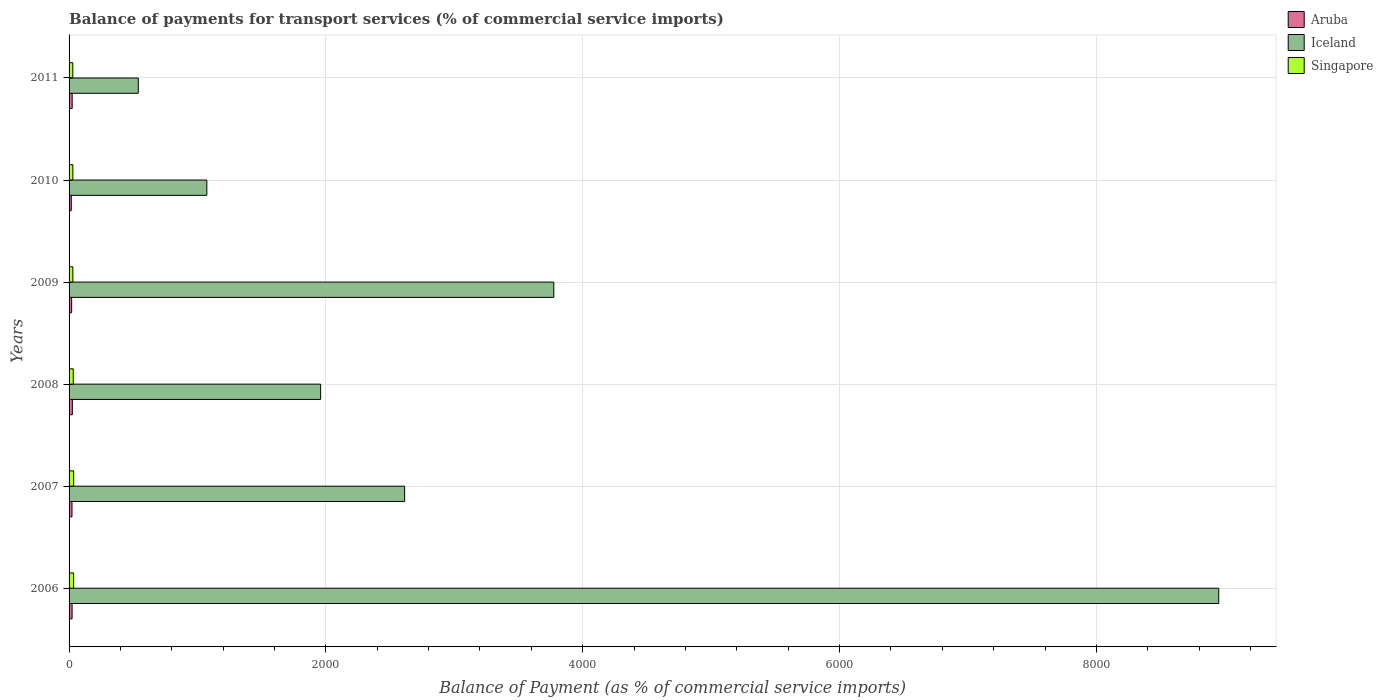How many different coloured bars are there?
Give a very brief answer. 3. Are the number of bars per tick equal to the number of legend labels?
Your response must be concise. Yes. What is the label of the 1st group of bars from the top?
Give a very brief answer. 2011. In how many cases, is the number of bars for a given year not equal to the number of legend labels?
Provide a short and direct response. 0. What is the balance of payments for transport services in Singapore in 2009?
Make the answer very short. 29.54. Across all years, what is the maximum balance of payments for transport services in Aruba?
Offer a terse response. 25.45. Across all years, what is the minimum balance of payments for transport services in Aruba?
Your answer should be compact. 17.18. In which year was the balance of payments for transport services in Aruba maximum?
Keep it short and to the point. 2008. What is the total balance of payments for transport services in Aruba in the graph?
Offer a terse response. 132.74. What is the difference between the balance of payments for transport services in Singapore in 2006 and that in 2008?
Make the answer very short. 2.6. What is the difference between the balance of payments for transport services in Iceland in 2011 and the balance of payments for transport services in Aruba in 2007?
Keep it short and to the point. 516.46. What is the average balance of payments for transport services in Iceland per year?
Keep it short and to the point. 3151.97. In the year 2011, what is the difference between the balance of payments for transport services in Singapore and balance of payments for transport services in Aruba?
Keep it short and to the point. 4.82. What is the ratio of the balance of payments for transport services in Aruba in 2007 to that in 2008?
Offer a very short reply. 0.89. Is the difference between the balance of payments for transport services in Singapore in 2010 and 2011 greater than the difference between the balance of payments for transport services in Aruba in 2010 and 2011?
Ensure brevity in your answer.  Yes. What is the difference between the highest and the second highest balance of payments for transport services in Singapore?
Make the answer very short. 0.41. What is the difference between the highest and the lowest balance of payments for transport services in Aruba?
Your answer should be compact. 8.27. What does the 1st bar from the top in 2006 represents?
Provide a short and direct response. Singapore. What does the 3rd bar from the bottom in 2007 represents?
Your response must be concise. Singapore. Are all the bars in the graph horizontal?
Provide a succinct answer. Yes. How many years are there in the graph?
Ensure brevity in your answer.  6. What is the difference between two consecutive major ticks on the X-axis?
Offer a very short reply. 2000. Does the graph contain any zero values?
Your response must be concise. No. Does the graph contain grids?
Your answer should be very brief. Yes. How many legend labels are there?
Make the answer very short. 3. How are the legend labels stacked?
Provide a short and direct response. Vertical. What is the title of the graph?
Give a very brief answer. Balance of payments for transport services (% of commercial service imports). Does "Paraguay" appear as one of the legend labels in the graph?
Provide a succinct answer. No. What is the label or title of the X-axis?
Offer a terse response. Balance of Payment (as % of commercial service imports). What is the Balance of Payment (as % of commercial service imports) of Aruba in 2006?
Offer a terse response. 23.38. What is the Balance of Payment (as % of commercial service imports) of Iceland in 2006?
Your answer should be compact. 8952.73. What is the Balance of Payment (as % of commercial service imports) in Singapore in 2006?
Make the answer very short. 35.42. What is the Balance of Payment (as % of commercial service imports) of Aruba in 2007?
Provide a short and direct response. 22.61. What is the Balance of Payment (as % of commercial service imports) in Iceland in 2007?
Your answer should be compact. 2613.27. What is the Balance of Payment (as % of commercial service imports) in Singapore in 2007?
Provide a succinct answer. 35.83. What is the Balance of Payment (as % of commercial service imports) of Aruba in 2008?
Your response must be concise. 25.45. What is the Balance of Payment (as % of commercial service imports) in Iceland in 2008?
Provide a short and direct response. 1959.06. What is the Balance of Payment (as % of commercial service imports) in Singapore in 2008?
Provide a succinct answer. 32.82. What is the Balance of Payment (as % of commercial service imports) in Aruba in 2009?
Offer a very short reply. 19.96. What is the Balance of Payment (as % of commercial service imports) of Iceland in 2009?
Your answer should be compact. 3774.93. What is the Balance of Payment (as % of commercial service imports) of Singapore in 2009?
Your answer should be compact. 29.54. What is the Balance of Payment (as % of commercial service imports) of Aruba in 2010?
Provide a short and direct response. 17.18. What is the Balance of Payment (as % of commercial service imports) in Iceland in 2010?
Keep it short and to the point. 1072.78. What is the Balance of Payment (as % of commercial service imports) in Singapore in 2010?
Your answer should be very brief. 29.47. What is the Balance of Payment (as % of commercial service imports) of Aruba in 2011?
Give a very brief answer. 24.16. What is the Balance of Payment (as % of commercial service imports) in Iceland in 2011?
Offer a terse response. 539.07. What is the Balance of Payment (as % of commercial service imports) in Singapore in 2011?
Provide a short and direct response. 28.98. Across all years, what is the maximum Balance of Payment (as % of commercial service imports) of Aruba?
Your answer should be compact. 25.45. Across all years, what is the maximum Balance of Payment (as % of commercial service imports) of Iceland?
Offer a terse response. 8952.73. Across all years, what is the maximum Balance of Payment (as % of commercial service imports) of Singapore?
Your response must be concise. 35.83. Across all years, what is the minimum Balance of Payment (as % of commercial service imports) of Aruba?
Your answer should be very brief. 17.18. Across all years, what is the minimum Balance of Payment (as % of commercial service imports) of Iceland?
Keep it short and to the point. 539.07. Across all years, what is the minimum Balance of Payment (as % of commercial service imports) in Singapore?
Offer a terse response. 28.98. What is the total Balance of Payment (as % of commercial service imports) of Aruba in the graph?
Offer a terse response. 132.74. What is the total Balance of Payment (as % of commercial service imports) of Iceland in the graph?
Ensure brevity in your answer.  1.89e+04. What is the total Balance of Payment (as % of commercial service imports) of Singapore in the graph?
Your answer should be very brief. 192.06. What is the difference between the Balance of Payment (as % of commercial service imports) of Aruba in 2006 and that in 2007?
Provide a succinct answer. 0.77. What is the difference between the Balance of Payment (as % of commercial service imports) in Iceland in 2006 and that in 2007?
Ensure brevity in your answer.  6339.46. What is the difference between the Balance of Payment (as % of commercial service imports) of Singapore in 2006 and that in 2007?
Offer a terse response. -0.41. What is the difference between the Balance of Payment (as % of commercial service imports) of Aruba in 2006 and that in 2008?
Ensure brevity in your answer.  -2.07. What is the difference between the Balance of Payment (as % of commercial service imports) of Iceland in 2006 and that in 2008?
Offer a very short reply. 6993.67. What is the difference between the Balance of Payment (as % of commercial service imports) of Singapore in 2006 and that in 2008?
Your answer should be very brief. 2.6. What is the difference between the Balance of Payment (as % of commercial service imports) in Aruba in 2006 and that in 2009?
Keep it short and to the point. 3.42. What is the difference between the Balance of Payment (as % of commercial service imports) of Iceland in 2006 and that in 2009?
Your response must be concise. 5177.8. What is the difference between the Balance of Payment (as % of commercial service imports) of Singapore in 2006 and that in 2009?
Make the answer very short. 5.88. What is the difference between the Balance of Payment (as % of commercial service imports) in Aruba in 2006 and that in 2010?
Ensure brevity in your answer.  6.2. What is the difference between the Balance of Payment (as % of commercial service imports) in Iceland in 2006 and that in 2010?
Your answer should be compact. 7879.95. What is the difference between the Balance of Payment (as % of commercial service imports) in Singapore in 2006 and that in 2010?
Ensure brevity in your answer.  5.95. What is the difference between the Balance of Payment (as % of commercial service imports) of Aruba in 2006 and that in 2011?
Provide a succinct answer. -0.78. What is the difference between the Balance of Payment (as % of commercial service imports) in Iceland in 2006 and that in 2011?
Make the answer very short. 8413.66. What is the difference between the Balance of Payment (as % of commercial service imports) in Singapore in 2006 and that in 2011?
Your answer should be compact. 6.44. What is the difference between the Balance of Payment (as % of commercial service imports) in Aruba in 2007 and that in 2008?
Your response must be concise. -2.85. What is the difference between the Balance of Payment (as % of commercial service imports) in Iceland in 2007 and that in 2008?
Your answer should be compact. 654.21. What is the difference between the Balance of Payment (as % of commercial service imports) in Singapore in 2007 and that in 2008?
Provide a succinct answer. 3.01. What is the difference between the Balance of Payment (as % of commercial service imports) in Aruba in 2007 and that in 2009?
Your response must be concise. 2.64. What is the difference between the Balance of Payment (as % of commercial service imports) of Iceland in 2007 and that in 2009?
Your answer should be compact. -1161.66. What is the difference between the Balance of Payment (as % of commercial service imports) in Singapore in 2007 and that in 2009?
Give a very brief answer. 6.29. What is the difference between the Balance of Payment (as % of commercial service imports) of Aruba in 2007 and that in 2010?
Provide a short and direct response. 5.43. What is the difference between the Balance of Payment (as % of commercial service imports) of Iceland in 2007 and that in 2010?
Offer a terse response. 1540.48. What is the difference between the Balance of Payment (as % of commercial service imports) of Singapore in 2007 and that in 2010?
Provide a succinct answer. 6.36. What is the difference between the Balance of Payment (as % of commercial service imports) of Aruba in 2007 and that in 2011?
Provide a short and direct response. -1.55. What is the difference between the Balance of Payment (as % of commercial service imports) of Iceland in 2007 and that in 2011?
Ensure brevity in your answer.  2074.2. What is the difference between the Balance of Payment (as % of commercial service imports) of Singapore in 2007 and that in 2011?
Keep it short and to the point. 6.85. What is the difference between the Balance of Payment (as % of commercial service imports) of Aruba in 2008 and that in 2009?
Give a very brief answer. 5.49. What is the difference between the Balance of Payment (as % of commercial service imports) of Iceland in 2008 and that in 2009?
Make the answer very short. -1815.87. What is the difference between the Balance of Payment (as % of commercial service imports) of Singapore in 2008 and that in 2009?
Offer a very short reply. 3.28. What is the difference between the Balance of Payment (as % of commercial service imports) in Aruba in 2008 and that in 2010?
Your answer should be compact. 8.27. What is the difference between the Balance of Payment (as % of commercial service imports) of Iceland in 2008 and that in 2010?
Make the answer very short. 886.28. What is the difference between the Balance of Payment (as % of commercial service imports) in Singapore in 2008 and that in 2010?
Ensure brevity in your answer.  3.35. What is the difference between the Balance of Payment (as % of commercial service imports) of Aruba in 2008 and that in 2011?
Offer a very short reply. 1.29. What is the difference between the Balance of Payment (as % of commercial service imports) in Iceland in 2008 and that in 2011?
Ensure brevity in your answer.  1419.99. What is the difference between the Balance of Payment (as % of commercial service imports) of Singapore in 2008 and that in 2011?
Offer a very short reply. 3.84. What is the difference between the Balance of Payment (as % of commercial service imports) of Aruba in 2009 and that in 2010?
Give a very brief answer. 2.78. What is the difference between the Balance of Payment (as % of commercial service imports) of Iceland in 2009 and that in 2010?
Your answer should be very brief. 2702.14. What is the difference between the Balance of Payment (as % of commercial service imports) of Singapore in 2009 and that in 2010?
Give a very brief answer. 0.07. What is the difference between the Balance of Payment (as % of commercial service imports) in Aruba in 2009 and that in 2011?
Provide a short and direct response. -4.2. What is the difference between the Balance of Payment (as % of commercial service imports) of Iceland in 2009 and that in 2011?
Keep it short and to the point. 3235.86. What is the difference between the Balance of Payment (as % of commercial service imports) in Singapore in 2009 and that in 2011?
Offer a very short reply. 0.56. What is the difference between the Balance of Payment (as % of commercial service imports) of Aruba in 2010 and that in 2011?
Provide a succinct answer. -6.98. What is the difference between the Balance of Payment (as % of commercial service imports) of Iceland in 2010 and that in 2011?
Your response must be concise. 533.71. What is the difference between the Balance of Payment (as % of commercial service imports) in Singapore in 2010 and that in 2011?
Ensure brevity in your answer.  0.49. What is the difference between the Balance of Payment (as % of commercial service imports) of Aruba in 2006 and the Balance of Payment (as % of commercial service imports) of Iceland in 2007?
Your response must be concise. -2589.89. What is the difference between the Balance of Payment (as % of commercial service imports) in Aruba in 2006 and the Balance of Payment (as % of commercial service imports) in Singapore in 2007?
Ensure brevity in your answer.  -12.45. What is the difference between the Balance of Payment (as % of commercial service imports) of Iceland in 2006 and the Balance of Payment (as % of commercial service imports) of Singapore in 2007?
Provide a succinct answer. 8916.9. What is the difference between the Balance of Payment (as % of commercial service imports) of Aruba in 2006 and the Balance of Payment (as % of commercial service imports) of Iceland in 2008?
Provide a short and direct response. -1935.68. What is the difference between the Balance of Payment (as % of commercial service imports) of Aruba in 2006 and the Balance of Payment (as % of commercial service imports) of Singapore in 2008?
Ensure brevity in your answer.  -9.44. What is the difference between the Balance of Payment (as % of commercial service imports) of Iceland in 2006 and the Balance of Payment (as % of commercial service imports) of Singapore in 2008?
Provide a short and direct response. 8919.91. What is the difference between the Balance of Payment (as % of commercial service imports) of Aruba in 2006 and the Balance of Payment (as % of commercial service imports) of Iceland in 2009?
Your answer should be very brief. -3751.55. What is the difference between the Balance of Payment (as % of commercial service imports) of Aruba in 2006 and the Balance of Payment (as % of commercial service imports) of Singapore in 2009?
Give a very brief answer. -6.16. What is the difference between the Balance of Payment (as % of commercial service imports) in Iceland in 2006 and the Balance of Payment (as % of commercial service imports) in Singapore in 2009?
Offer a terse response. 8923.19. What is the difference between the Balance of Payment (as % of commercial service imports) in Aruba in 2006 and the Balance of Payment (as % of commercial service imports) in Iceland in 2010?
Your answer should be compact. -1049.4. What is the difference between the Balance of Payment (as % of commercial service imports) in Aruba in 2006 and the Balance of Payment (as % of commercial service imports) in Singapore in 2010?
Offer a terse response. -6.09. What is the difference between the Balance of Payment (as % of commercial service imports) of Iceland in 2006 and the Balance of Payment (as % of commercial service imports) of Singapore in 2010?
Provide a short and direct response. 8923.26. What is the difference between the Balance of Payment (as % of commercial service imports) in Aruba in 2006 and the Balance of Payment (as % of commercial service imports) in Iceland in 2011?
Keep it short and to the point. -515.69. What is the difference between the Balance of Payment (as % of commercial service imports) in Aruba in 2006 and the Balance of Payment (as % of commercial service imports) in Singapore in 2011?
Keep it short and to the point. -5.6. What is the difference between the Balance of Payment (as % of commercial service imports) in Iceland in 2006 and the Balance of Payment (as % of commercial service imports) in Singapore in 2011?
Offer a terse response. 8923.75. What is the difference between the Balance of Payment (as % of commercial service imports) in Aruba in 2007 and the Balance of Payment (as % of commercial service imports) in Iceland in 2008?
Your response must be concise. -1936.46. What is the difference between the Balance of Payment (as % of commercial service imports) in Aruba in 2007 and the Balance of Payment (as % of commercial service imports) in Singapore in 2008?
Your response must be concise. -10.21. What is the difference between the Balance of Payment (as % of commercial service imports) in Iceland in 2007 and the Balance of Payment (as % of commercial service imports) in Singapore in 2008?
Provide a succinct answer. 2580.45. What is the difference between the Balance of Payment (as % of commercial service imports) of Aruba in 2007 and the Balance of Payment (as % of commercial service imports) of Iceland in 2009?
Provide a succinct answer. -3752.32. What is the difference between the Balance of Payment (as % of commercial service imports) of Aruba in 2007 and the Balance of Payment (as % of commercial service imports) of Singapore in 2009?
Offer a terse response. -6.93. What is the difference between the Balance of Payment (as % of commercial service imports) in Iceland in 2007 and the Balance of Payment (as % of commercial service imports) in Singapore in 2009?
Your response must be concise. 2583.73. What is the difference between the Balance of Payment (as % of commercial service imports) in Aruba in 2007 and the Balance of Payment (as % of commercial service imports) in Iceland in 2010?
Make the answer very short. -1050.18. What is the difference between the Balance of Payment (as % of commercial service imports) in Aruba in 2007 and the Balance of Payment (as % of commercial service imports) in Singapore in 2010?
Your answer should be compact. -6.87. What is the difference between the Balance of Payment (as % of commercial service imports) of Iceland in 2007 and the Balance of Payment (as % of commercial service imports) of Singapore in 2010?
Your answer should be compact. 2583.8. What is the difference between the Balance of Payment (as % of commercial service imports) of Aruba in 2007 and the Balance of Payment (as % of commercial service imports) of Iceland in 2011?
Your response must be concise. -516.46. What is the difference between the Balance of Payment (as % of commercial service imports) of Aruba in 2007 and the Balance of Payment (as % of commercial service imports) of Singapore in 2011?
Your answer should be very brief. -6.37. What is the difference between the Balance of Payment (as % of commercial service imports) in Iceland in 2007 and the Balance of Payment (as % of commercial service imports) in Singapore in 2011?
Your answer should be compact. 2584.29. What is the difference between the Balance of Payment (as % of commercial service imports) in Aruba in 2008 and the Balance of Payment (as % of commercial service imports) in Iceland in 2009?
Offer a very short reply. -3749.47. What is the difference between the Balance of Payment (as % of commercial service imports) in Aruba in 2008 and the Balance of Payment (as % of commercial service imports) in Singapore in 2009?
Ensure brevity in your answer.  -4.09. What is the difference between the Balance of Payment (as % of commercial service imports) in Iceland in 2008 and the Balance of Payment (as % of commercial service imports) in Singapore in 2009?
Offer a very short reply. 1929.52. What is the difference between the Balance of Payment (as % of commercial service imports) of Aruba in 2008 and the Balance of Payment (as % of commercial service imports) of Iceland in 2010?
Provide a succinct answer. -1047.33. What is the difference between the Balance of Payment (as % of commercial service imports) of Aruba in 2008 and the Balance of Payment (as % of commercial service imports) of Singapore in 2010?
Provide a short and direct response. -4.02. What is the difference between the Balance of Payment (as % of commercial service imports) of Iceland in 2008 and the Balance of Payment (as % of commercial service imports) of Singapore in 2010?
Offer a terse response. 1929.59. What is the difference between the Balance of Payment (as % of commercial service imports) in Aruba in 2008 and the Balance of Payment (as % of commercial service imports) in Iceland in 2011?
Give a very brief answer. -513.62. What is the difference between the Balance of Payment (as % of commercial service imports) of Aruba in 2008 and the Balance of Payment (as % of commercial service imports) of Singapore in 2011?
Your answer should be compact. -3.53. What is the difference between the Balance of Payment (as % of commercial service imports) of Iceland in 2008 and the Balance of Payment (as % of commercial service imports) of Singapore in 2011?
Make the answer very short. 1930.08. What is the difference between the Balance of Payment (as % of commercial service imports) of Aruba in 2009 and the Balance of Payment (as % of commercial service imports) of Iceland in 2010?
Offer a terse response. -1052.82. What is the difference between the Balance of Payment (as % of commercial service imports) of Aruba in 2009 and the Balance of Payment (as % of commercial service imports) of Singapore in 2010?
Make the answer very short. -9.51. What is the difference between the Balance of Payment (as % of commercial service imports) of Iceland in 2009 and the Balance of Payment (as % of commercial service imports) of Singapore in 2010?
Your response must be concise. 3745.46. What is the difference between the Balance of Payment (as % of commercial service imports) of Aruba in 2009 and the Balance of Payment (as % of commercial service imports) of Iceland in 2011?
Your response must be concise. -519.11. What is the difference between the Balance of Payment (as % of commercial service imports) in Aruba in 2009 and the Balance of Payment (as % of commercial service imports) in Singapore in 2011?
Offer a terse response. -9.02. What is the difference between the Balance of Payment (as % of commercial service imports) of Iceland in 2009 and the Balance of Payment (as % of commercial service imports) of Singapore in 2011?
Make the answer very short. 3745.95. What is the difference between the Balance of Payment (as % of commercial service imports) of Aruba in 2010 and the Balance of Payment (as % of commercial service imports) of Iceland in 2011?
Your response must be concise. -521.89. What is the difference between the Balance of Payment (as % of commercial service imports) in Aruba in 2010 and the Balance of Payment (as % of commercial service imports) in Singapore in 2011?
Keep it short and to the point. -11.8. What is the difference between the Balance of Payment (as % of commercial service imports) of Iceland in 2010 and the Balance of Payment (as % of commercial service imports) of Singapore in 2011?
Make the answer very short. 1043.8. What is the average Balance of Payment (as % of commercial service imports) of Aruba per year?
Offer a terse response. 22.12. What is the average Balance of Payment (as % of commercial service imports) in Iceland per year?
Give a very brief answer. 3151.97. What is the average Balance of Payment (as % of commercial service imports) of Singapore per year?
Provide a succinct answer. 32.01. In the year 2006, what is the difference between the Balance of Payment (as % of commercial service imports) of Aruba and Balance of Payment (as % of commercial service imports) of Iceland?
Give a very brief answer. -8929.35. In the year 2006, what is the difference between the Balance of Payment (as % of commercial service imports) of Aruba and Balance of Payment (as % of commercial service imports) of Singapore?
Your response must be concise. -12.04. In the year 2006, what is the difference between the Balance of Payment (as % of commercial service imports) of Iceland and Balance of Payment (as % of commercial service imports) of Singapore?
Provide a short and direct response. 8917.31. In the year 2007, what is the difference between the Balance of Payment (as % of commercial service imports) in Aruba and Balance of Payment (as % of commercial service imports) in Iceland?
Your answer should be very brief. -2590.66. In the year 2007, what is the difference between the Balance of Payment (as % of commercial service imports) in Aruba and Balance of Payment (as % of commercial service imports) in Singapore?
Offer a terse response. -13.22. In the year 2007, what is the difference between the Balance of Payment (as % of commercial service imports) of Iceland and Balance of Payment (as % of commercial service imports) of Singapore?
Provide a short and direct response. 2577.44. In the year 2008, what is the difference between the Balance of Payment (as % of commercial service imports) of Aruba and Balance of Payment (as % of commercial service imports) of Iceland?
Your answer should be very brief. -1933.61. In the year 2008, what is the difference between the Balance of Payment (as % of commercial service imports) in Aruba and Balance of Payment (as % of commercial service imports) in Singapore?
Your answer should be compact. -7.37. In the year 2008, what is the difference between the Balance of Payment (as % of commercial service imports) in Iceland and Balance of Payment (as % of commercial service imports) in Singapore?
Make the answer very short. 1926.24. In the year 2009, what is the difference between the Balance of Payment (as % of commercial service imports) in Aruba and Balance of Payment (as % of commercial service imports) in Iceland?
Provide a short and direct response. -3754.96. In the year 2009, what is the difference between the Balance of Payment (as % of commercial service imports) in Aruba and Balance of Payment (as % of commercial service imports) in Singapore?
Ensure brevity in your answer.  -9.58. In the year 2009, what is the difference between the Balance of Payment (as % of commercial service imports) in Iceland and Balance of Payment (as % of commercial service imports) in Singapore?
Keep it short and to the point. 3745.39. In the year 2010, what is the difference between the Balance of Payment (as % of commercial service imports) in Aruba and Balance of Payment (as % of commercial service imports) in Iceland?
Offer a terse response. -1055.6. In the year 2010, what is the difference between the Balance of Payment (as % of commercial service imports) in Aruba and Balance of Payment (as % of commercial service imports) in Singapore?
Provide a succinct answer. -12.29. In the year 2010, what is the difference between the Balance of Payment (as % of commercial service imports) of Iceland and Balance of Payment (as % of commercial service imports) of Singapore?
Provide a succinct answer. 1043.31. In the year 2011, what is the difference between the Balance of Payment (as % of commercial service imports) of Aruba and Balance of Payment (as % of commercial service imports) of Iceland?
Give a very brief answer. -514.91. In the year 2011, what is the difference between the Balance of Payment (as % of commercial service imports) of Aruba and Balance of Payment (as % of commercial service imports) of Singapore?
Your answer should be very brief. -4.82. In the year 2011, what is the difference between the Balance of Payment (as % of commercial service imports) of Iceland and Balance of Payment (as % of commercial service imports) of Singapore?
Offer a very short reply. 510.09. What is the ratio of the Balance of Payment (as % of commercial service imports) in Aruba in 2006 to that in 2007?
Ensure brevity in your answer.  1.03. What is the ratio of the Balance of Payment (as % of commercial service imports) in Iceland in 2006 to that in 2007?
Ensure brevity in your answer.  3.43. What is the ratio of the Balance of Payment (as % of commercial service imports) in Aruba in 2006 to that in 2008?
Ensure brevity in your answer.  0.92. What is the ratio of the Balance of Payment (as % of commercial service imports) of Iceland in 2006 to that in 2008?
Keep it short and to the point. 4.57. What is the ratio of the Balance of Payment (as % of commercial service imports) of Singapore in 2006 to that in 2008?
Make the answer very short. 1.08. What is the ratio of the Balance of Payment (as % of commercial service imports) of Aruba in 2006 to that in 2009?
Give a very brief answer. 1.17. What is the ratio of the Balance of Payment (as % of commercial service imports) of Iceland in 2006 to that in 2009?
Your answer should be compact. 2.37. What is the ratio of the Balance of Payment (as % of commercial service imports) in Singapore in 2006 to that in 2009?
Offer a terse response. 1.2. What is the ratio of the Balance of Payment (as % of commercial service imports) in Aruba in 2006 to that in 2010?
Provide a succinct answer. 1.36. What is the ratio of the Balance of Payment (as % of commercial service imports) of Iceland in 2006 to that in 2010?
Your answer should be compact. 8.35. What is the ratio of the Balance of Payment (as % of commercial service imports) in Singapore in 2006 to that in 2010?
Offer a very short reply. 1.2. What is the ratio of the Balance of Payment (as % of commercial service imports) of Iceland in 2006 to that in 2011?
Provide a succinct answer. 16.61. What is the ratio of the Balance of Payment (as % of commercial service imports) in Singapore in 2006 to that in 2011?
Keep it short and to the point. 1.22. What is the ratio of the Balance of Payment (as % of commercial service imports) in Aruba in 2007 to that in 2008?
Provide a succinct answer. 0.89. What is the ratio of the Balance of Payment (as % of commercial service imports) of Iceland in 2007 to that in 2008?
Provide a short and direct response. 1.33. What is the ratio of the Balance of Payment (as % of commercial service imports) in Singapore in 2007 to that in 2008?
Ensure brevity in your answer.  1.09. What is the ratio of the Balance of Payment (as % of commercial service imports) in Aruba in 2007 to that in 2009?
Keep it short and to the point. 1.13. What is the ratio of the Balance of Payment (as % of commercial service imports) in Iceland in 2007 to that in 2009?
Offer a terse response. 0.69. What is the ratio of the Balance of Payment (as % of commercial service imports) of Singapore in 2007 to that in 2009?
Keep it short and to the point. 1.21. What is the ratio of the Balance of Payment (as % of commercial service imports) in Aruba in 2007 to that in 2010?
Ensure brevity in your answer.  1.32. What is the ratio of the Balance of Payment (as % of commercial service imports) of Iceland in 2007 to that in 2010?
Give a very brief answer. 2.44. What is the ratio of the Balance of Payment (as % of commercial service imports) of Singapore in 2007 to that in 2010?
Provide a succinct answer. 1.22. What is the ratio of the Balance of Payment (as % of commercial service imports) in Aruba in 2007 to that in 2011?
Ensure brevity in your answer.  0.94. What is the ratio of the Balance of Payment (as % of commercial service imports) of Iceland in 2007 to that in 2011?
Make the answer very short. 4.85. What is the ratio of the Balance of Payment (as % of commercial service imports) in Singapore in 2007 to that in 2011?
Offer a very short reply. 1.24. What is the ratio of the Balance of Payment (as % of commercial service imports) of Aruba in 2008 to that in 2009?
Your answer should be compact. 1.27. What is the ratio of the Balance of Payment (as % of commercial service imports) of Iceland in 2008 to that in 2009?
Provide a succinct answer. 0.52. What is the ratio of the Balance of Payment (as % of commercial service imports) of Singapore in 2008 to that in 2009?
Provide a succinct answer. 1.11. What is the ratio of the Balance of Payment (as % of commercial service imports) of Aruba in 2008 to that in 2010?
Offer a terse response. 1.48. What is the ratio of the Balance of Payment (as % of commercial service imports) of Iceland in 2008 to that in 2010?
Give a very brief answer. 1.83. What is the ratio of the Balance of Payment (as % of commercial service imports) of Singapore in 2008 to that in 2010?
Ensure brevity in your answer.  1.11. What is the ratio of the Balance of Payment (as % of commercial service imports) of Aruba in 2008 to that in 2011?
Your answer should be compact. 1.05. What is the ratio of the Balance of Payment (as % of commercial service imports) of Iceland in 2008 to that in 2011?
Your answer should be very brief. 3.63. What is the ratio of the Balance of Payment (as % of commercial service imports) in Singapore in 2008 to that in 2011?
Offer a terse response. 1.13. What is the ratio of the Balance of Payment (as % of commercial service imports) of Aruba in 2009 to that in 2010?
Provide a short and direct response. 1.16. What is the ratio of the Balance of Payment (as % of commercial service imports) in Iceland in 2009 to that in 2010?
Your answer should be compact. 3.52. What is the ratio of the Balance of Payment (as % of commercial service imports) in Singapore in 2009 to that in 2010?
Your response must be concise. 1. What is the ratio of the Balance of Payment (as % of commercial service imports) in Aruba in 2009 to that in 2011?
Keep it short and to the point. 0.83. What is the ratio of the Balance of Payment (as % of commercial service imports) in Iceland in 2009 to that in 2011?
Provide a succinct answer. 7. What is the ratio of the Balance of Payment (as % of commercial service imports) of Singapore in 2009 to that in 2011?
Your response must be concise. 1.02. What is the ratio of the Balance of Payment (as % of commercial service imports) in Aruba in 2010 to that in 2011?
Your answer should be compact. 0.71. What is the ratio of the Balance of Payment (as % of commercial service imports) of Iceland in 2010 to that in 2011?
Provide a short and direct response. 1.99. What is the difference between the highest and the second highest Balance of Payment (as % of commercial service imports) of Aruba?
Make the answer very short. 1.29. What is the difference between the highest and the second highest Balance of Payment (as % of commercial service imports) of Iceland?
Your answer should be very brief. 5177.8. What is the difference between the highest and the second highest Balance of Payment (as % of commercial service imports) in Singapore?
Provide a short and direct response. 0.41. What is the difference between the highest and the lowest Balance of Payment (as % of commercial service imports) in Aruba?
Keep it short and to the point. 8.27. What is the difference between the highest and the lowest Balance of Payment (as % of commercial service imports) in Iceland?
Your answer should be very brief. 8413.66. What is the difference between the highest and the lowest Balance of Payment (as % of commercial service imports) in Singapore?
Your response must be concise. 6.85. 